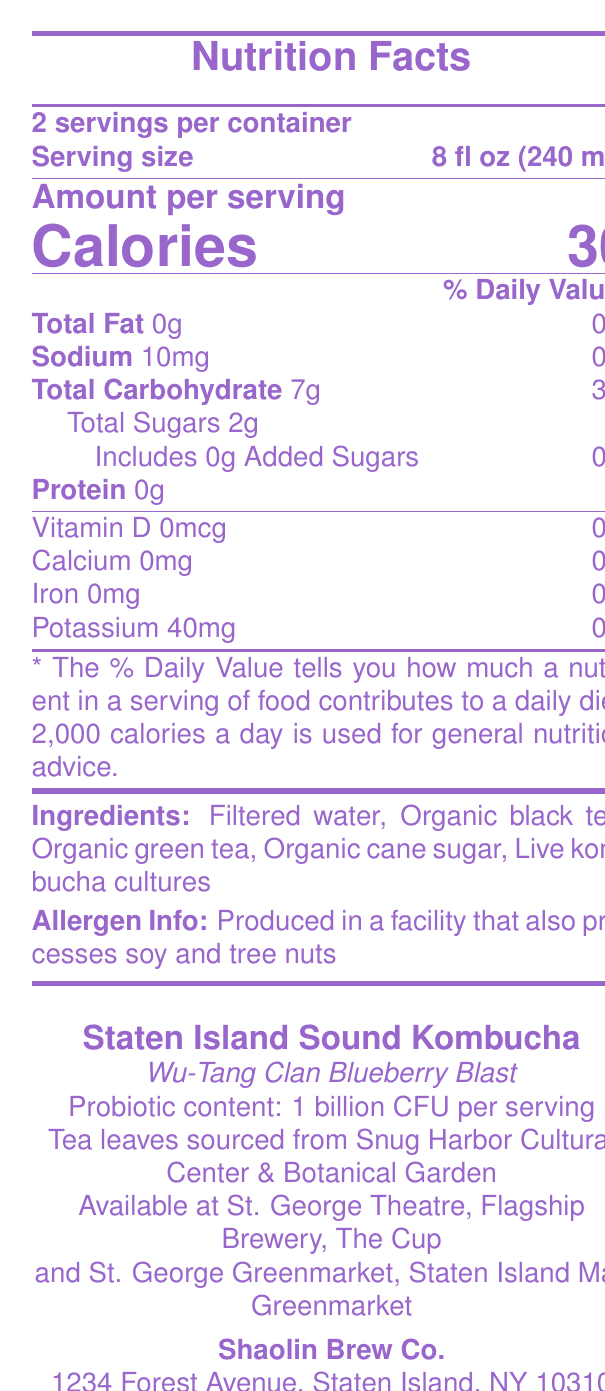what is the serving size of Staten Island Sound Kombucha? The serving size is explicitly stated as "8 fl oz (240 mL)" in the document.
Answer: 8 fl oz (240 mL) how many calories are in one serving of Staten Island Sound Kombucha? The document states that each serving contains 30 calories.
Answer: 30 how many grams of total carbohydrates are in one serving? The Nutrition Facts section indicates there are 7 grams of total carbohydrates per serving.
Answer: 7g what is the probiotic content per serving? The document states that the probiotic content is "1 billion CFU per serving."
Answer: 1 billion CFU per serving what are the main ingredients listed for Staten Island Sound Kombucha? These ingredients are explicitly listed under the "Ingredients" section of the document.
Answer: Filtered water, Organic black tea, Organic green tea, Organic cane sugar, Live kombucha cultures is there any added sugar in Staten Island Sound Kombucha? The document specifies, "Includes 0g Added Sugars 0%," indicating no added sugars.
Answer: No what is the sodium content per serving? A. 5mg B. 10mg C. 15mg The Nutrition Facts state that the sodium content per serving is 10mg.
Answer: B. 10mg which of the following music venues sells Staten Island Sound Kombucha? I. St. George Theatre II. The Bowery Ballroom III. Flagship Brewery IV. Terminal 5 The document lists "St. George Theatre" and "Flagship Brewery" under the "Available at" section, but not "The Bowery Ballroom" or "Terminal 5."
Answer: I and III does Staten Island Sound Kombucha contain any protein? The document states that the amount of protein per serving is 0g.
Answer: No is the kombucha produced in a gluten-free facility? The allergen info only mentions it is produced in a facility that also processes soy and tree nuts, but there is no mention of gluten.
Answer: Not enough information which local place sources the tea leaves for Staten Island Sound Kombucha? The document states the tea leaves are sourced from "Snug Harbor Cultural Center & Botanical Garden."
Answer: Snug Harbor Cultural Center & Botanical Garden summarize the nutrition facts and key information of Staten Island Sound Kombucha. The summarized information outlines the nutrition facts, major ingredients, allergen info, and availability of the product.
Answer: Staten Island Sound Kombucha serves two per container with each serving size of 8 fl oz (240 mL). It has 30 calories per serving, 0g total fat, 10mg sodium, 7g total carbohydrates, 2g total sugars with no added sugars, and 0g protein. It contains 1 billion CFU of probiotics per serving. Ingredients include filtered water, organic black tea, organic green tea, organic cane sugar, and live kombucha cultures. It is produced in a facility that also processes soy and tree nuts and is available at St. George Theatre, Flagship Brewery, and The Cup. what type of packaging is used for Staten Island Sound Kombucha? The document states that it is packaged in a "recyclable glass bottle with artwork by local Staten Island artist."
Answer: Recyclable glass bottle with artwork by local Staten Island artist 